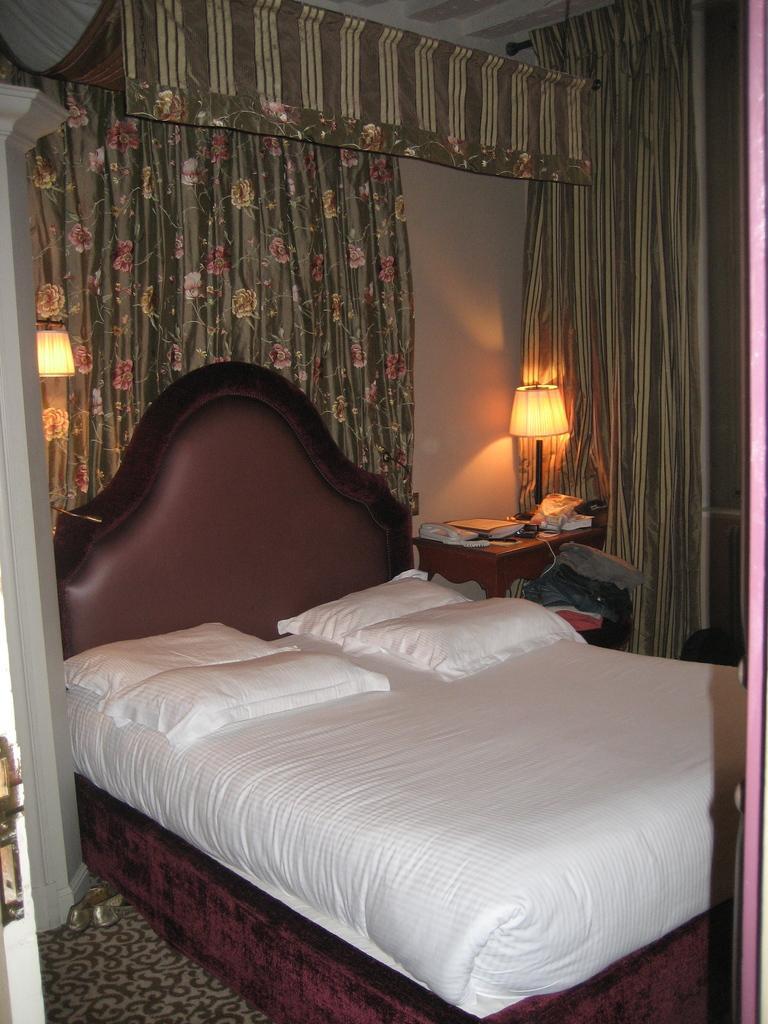Could you give a brief overview of what you see in this image? In this image I can see the bed, pillows, light, curtains and the wall. I can see the lamp, books and few objects on the table. 